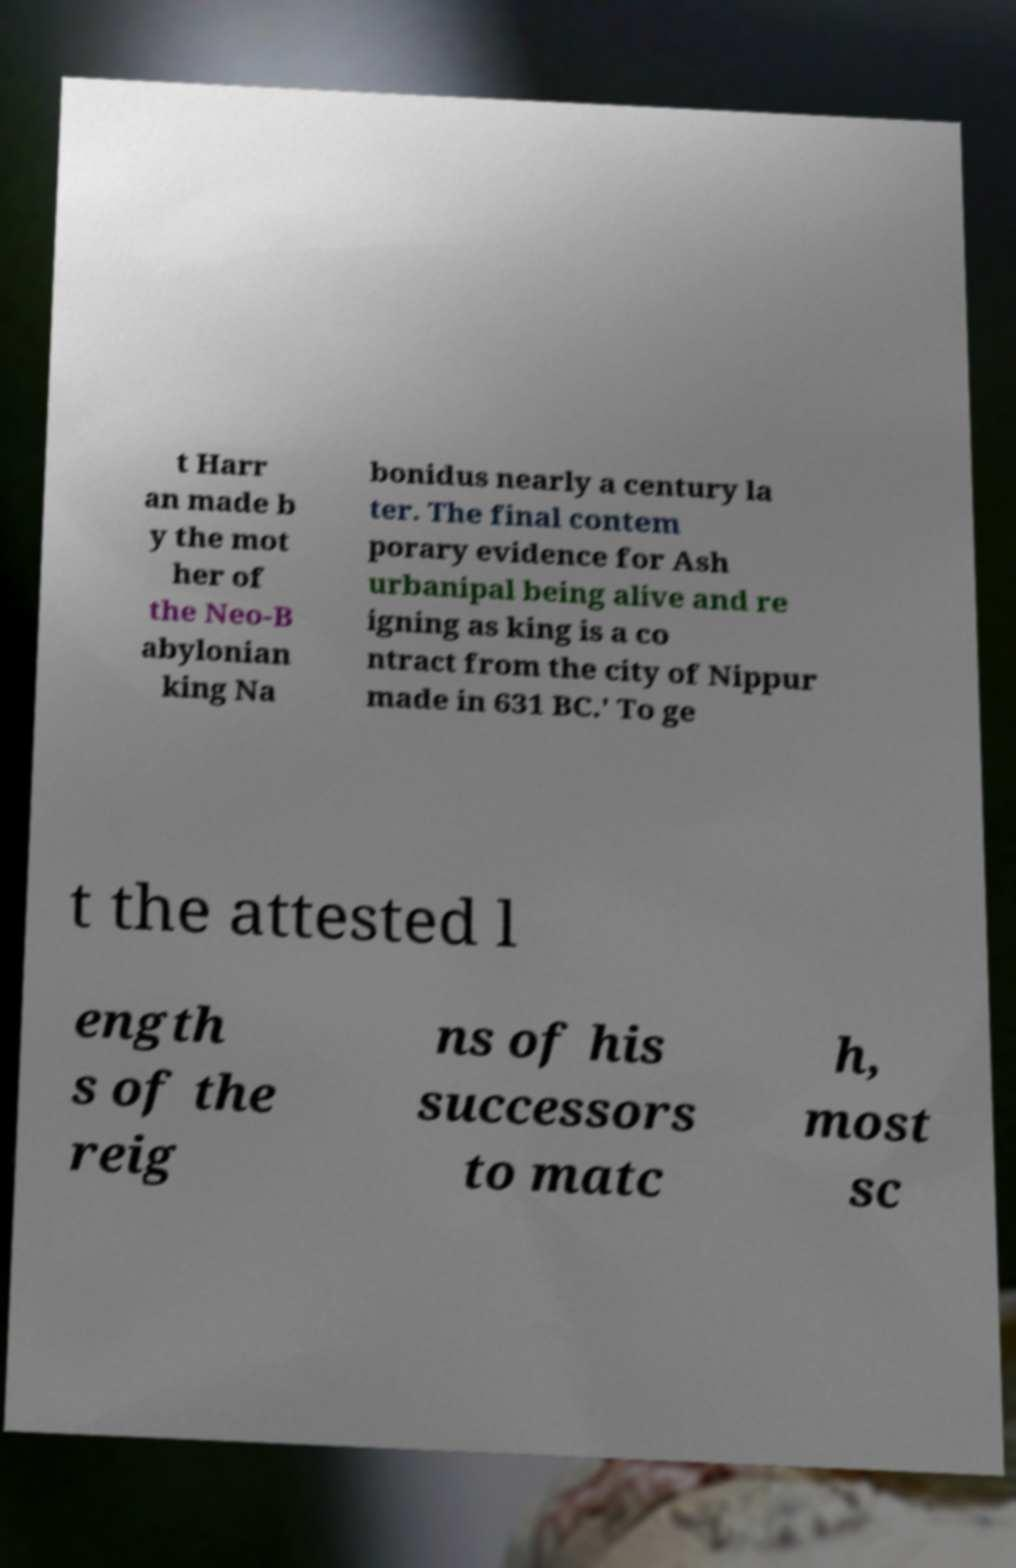What messages or text are displayed in this image? I need them in a readable, typed format. t Harr an made b y the mot her of the Neo-B abylonian king Na bonidus nearly a century la ter. The final contem porary evidence for Ash urbanipal being alive and re igning as king is a co ntract from the city of Nippur made in 631 BC.' To ge t the attested l ength s of the reig ns of his successors to matc h, most sc 